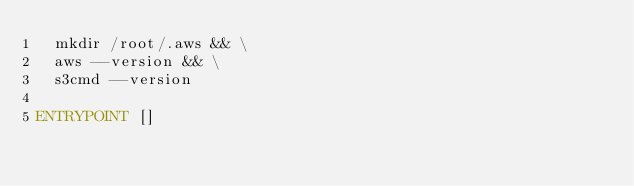Convert code to text. <code><loc_0><loc_0><loc_500><loc_500><_Dockerfile_>  mkdir /root/.aws && \
  aws --version && \
  s3cmd --version

ENTRYPOINT []
</code> 